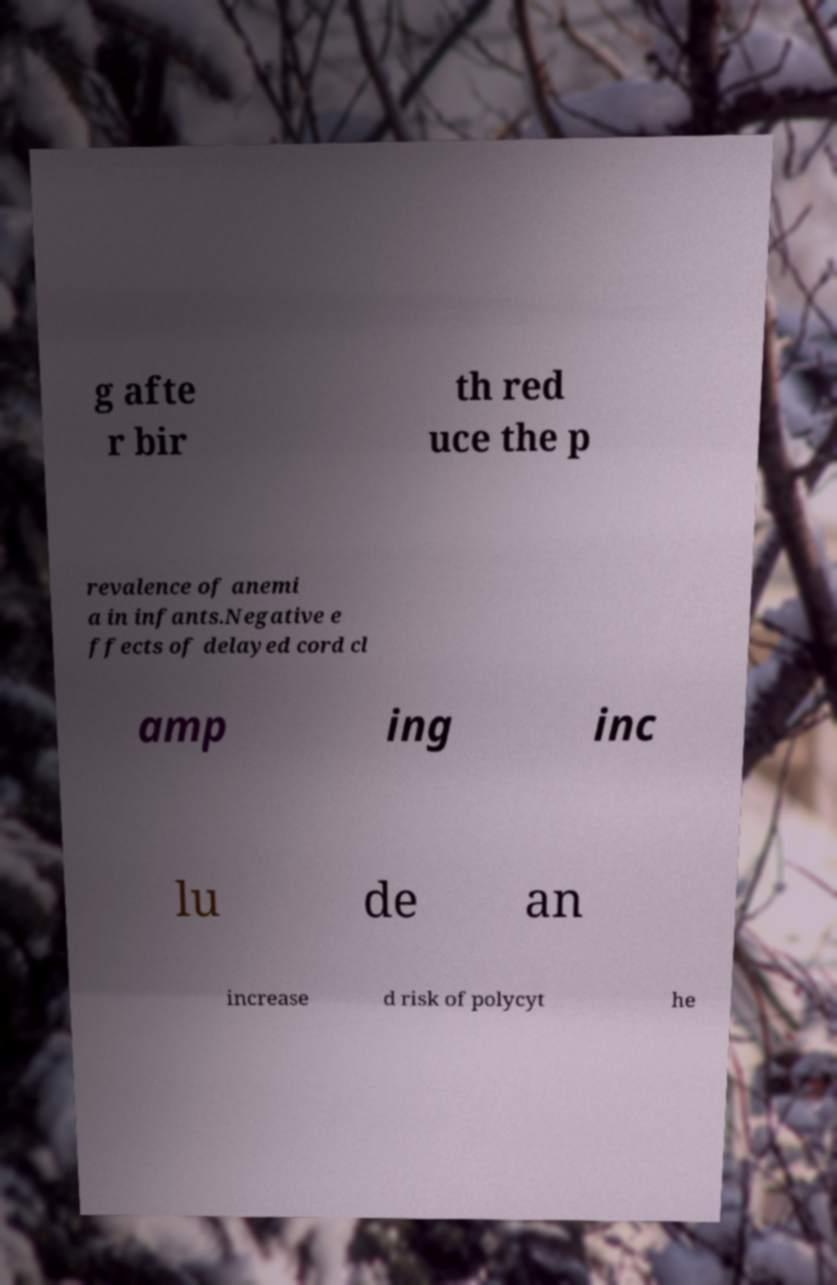Could you assist in decoding the text presented in this image and type it out clearly? g afte r bir th red uce the p revalence of anemi a in infants.Negative e ffects of delayed cord cl amp ing inc lu de an increase d risk of polycyt he 